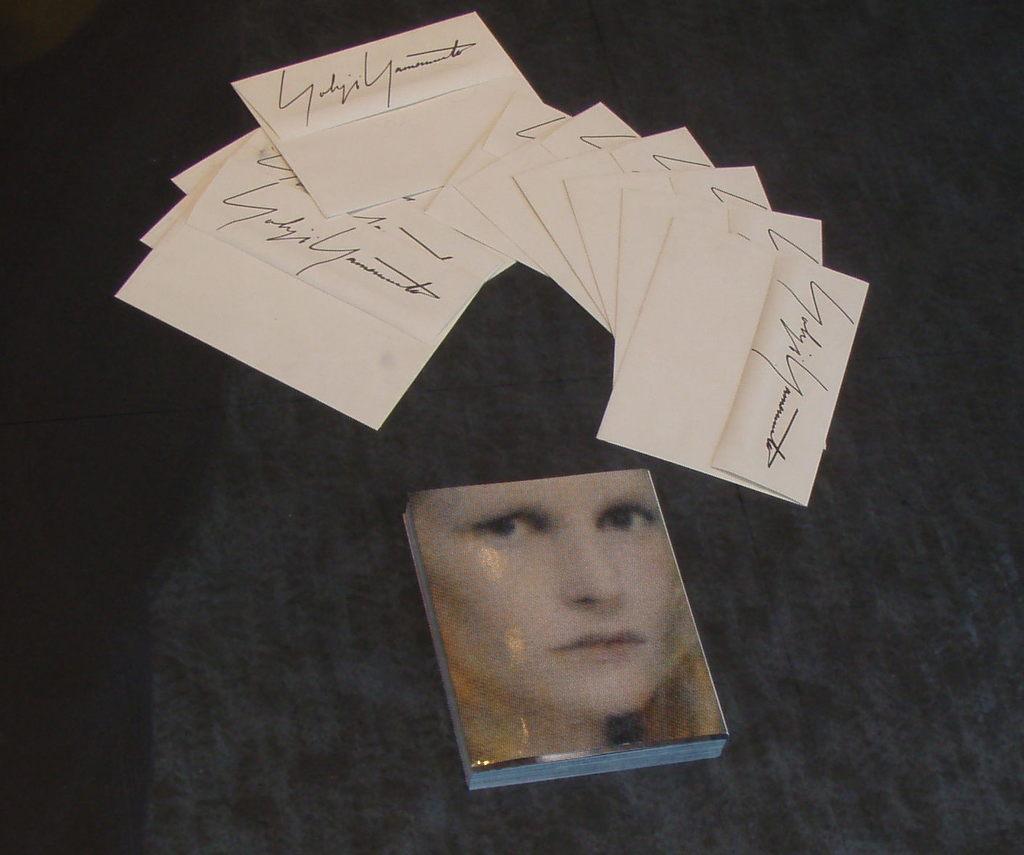Please provide a concise description of this image. In this image there is a book, in front of the book there are a few envelopes on the black color surface. 